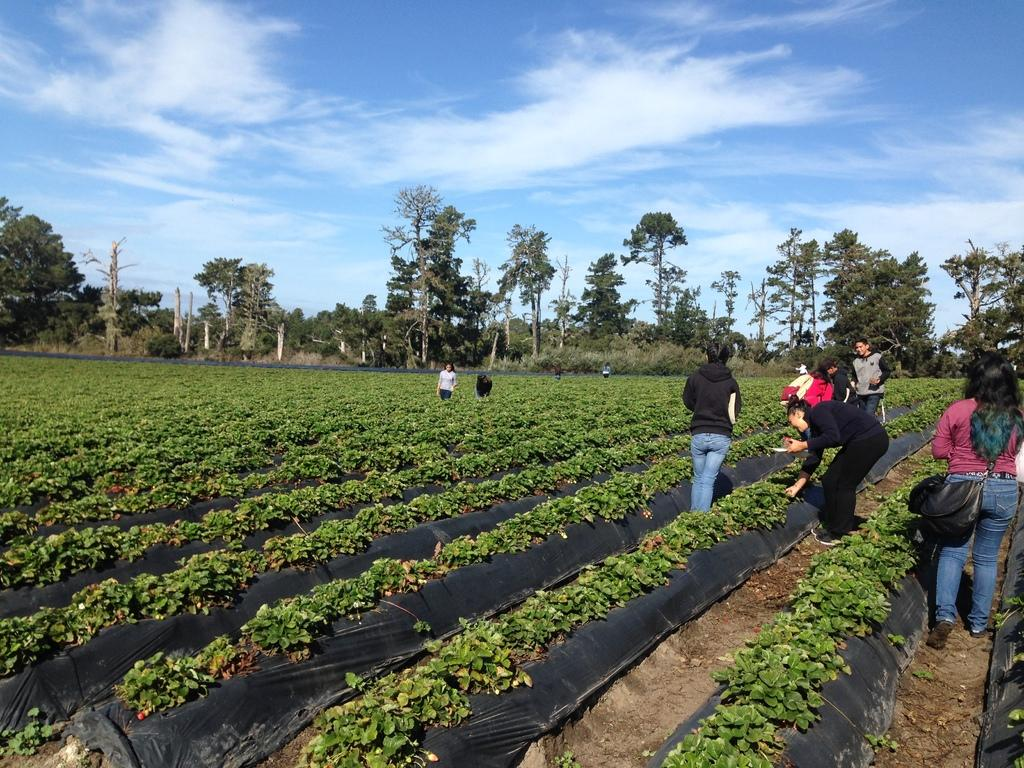What type of living organisms can be seen in the image? Plants and trees are visible in the image. Are there any human subjects in the image? Yes, there are people standing in the image. What can be seen in the sky in the image? There are clouds visible in the sky. How much salt is present in the image? There is no salt present in the image. What type of clouds can be seen in the image? The provided facts do not specify the type of clouds in the image, only that clouds are visible in the sky. 